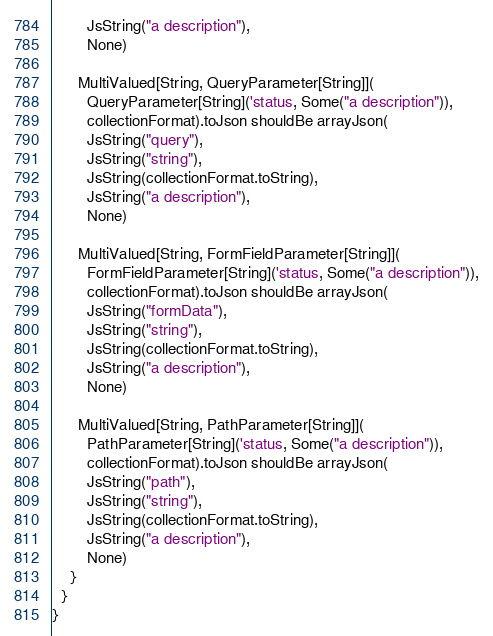Convert code to text. <code><loc_0><loc_0><loc_500><loc_500><_Scala_>        JsString("a description"),
        None)

      MultiValued[String, QueryParameter[String]](
        QueryParameter[String]('status, Some("a description")),
        collectionFormat).toJson shouldBe arrayJson(
        JsString("query"),
        JsString("string"),
        JsString(collectionFormat.toString),
        JsString("a description"),
        None)

      MultiValued[String, FormFieldParameter[String]](
        FormFieldParameter[String]('status, Some("a description")),
        collectionFormat).toJson shouldBe arrayJson(
        JsString("formData"),
        JsString("string"),
        JsString(collectionFormat.toString),
        JsString("a description"),
        None)

      MultiValued[String, PathParameter[String]](
        PathParameter[String]('status, Some("a description")),
        collectionFormat).toJson shouldBe arrayJson(
        JsString("path"),
        JsString("string"),
        JsString(collectionFormat.toString),
        JsString("a description"),
        None)
    }
  }
}
</code> 